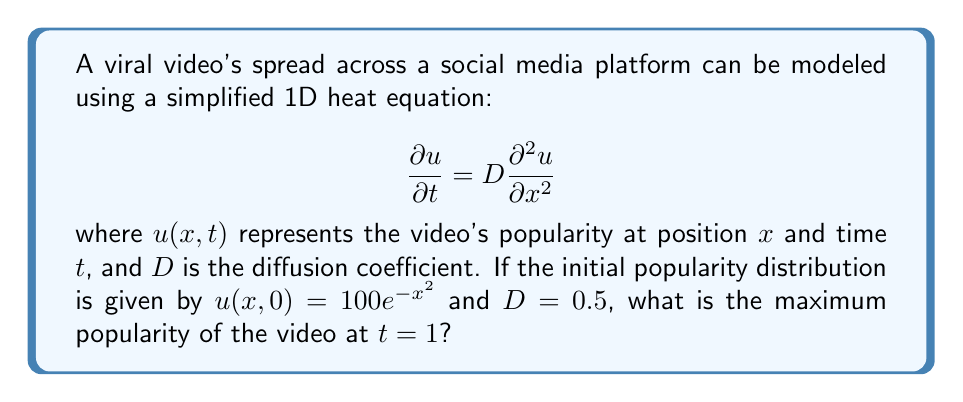Could you help me with this problem? To solve this problem, we'll use the fundamental solution of the 1D heat equation:

1) The solution to the heat equation with initial condition $u(x,0) = f(x)$ is given by:

   $$u(x,t) = \frac{1}{\sqrt{4\pi Dt}} \int_{-\infty}^{\infty} f(\xi) e^{-\frac{(x-\xi)^2}{4Dt}} d\xi$$

2) In our case, $f(x) = 100e^{-x^2}$ and $D = 0.5$. Substituting these into the solution:

   $$u(x,1) = \frac{1}{\sqrt{2\pi}} \int_{-\infty}^{\infty} 100e^{-\xi^2} e^{-\frac{(x-\xi)^2}{2}} d\xi$$

3) To find the maximum popularity, we need to evaluate this at $x = 0$ (due to symmetry):

   $$u(0,1) = \frac{100}{\sqrt{2\pi}} \int_{-\infty}^{\infty} e^{-\xi^2} e^{-\frac{\xi^2}{2}} d\xi$$

4) Simplifying the exponent:

   $$u(0,1) = \frac{100}{\sqrt{2\pi}} \int_{-\infty}^{\infty} e^{-\frac{3\xi^2}{2}} d\xi$$

5) This integral can be evaluated using the formula $\int_{-\infty}^{\infty} e^{-ax^2} dx = \sqrt{\frac{\pi}{a}}$:

   $$u(0,1) = \frac{100}{\sqrt{2\pi}} \cdot \sqrt{\frac{2\pi}{3}} = \frac{100}{\sqrt{3}}$$

6) Therefore, the maximum popularity at $t = 1$ is $\frac{100}{\sqrt{3}}$.
Answer: $\frac{100}{\sqrt{3}}$ 